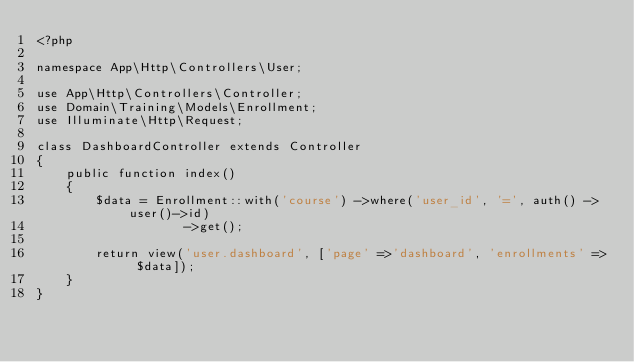<code> <loc_0><loc_0><loc_500><loc_500><_PHP_><?php

namespace App\Http\Controllers\User;

use App\Http\Controllers\Controller;
use Domain\Training\Models\Enrollment;
use Illuminate\Http\Request;

class DashboardController extends Controller
{
    public function index()
    {
        $data = Enrollment::with('course') ->where('user_id', '=', auth() ->user()->id)
                    ->get();

        return view('user.dashboard', ['page' =>'dashboard', 'enrollments' => $data]);
    }
}
</code> 